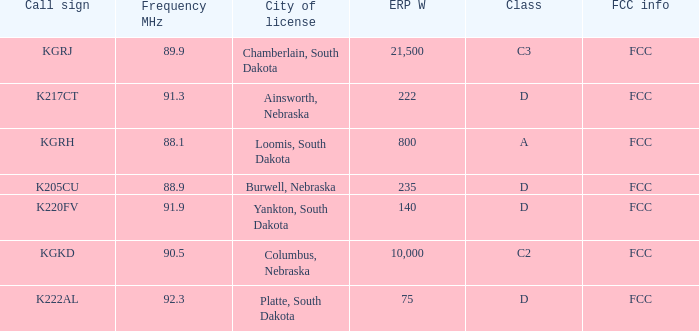What is the highest erp w with a 90.5 frequency mhz? 10000.0. 